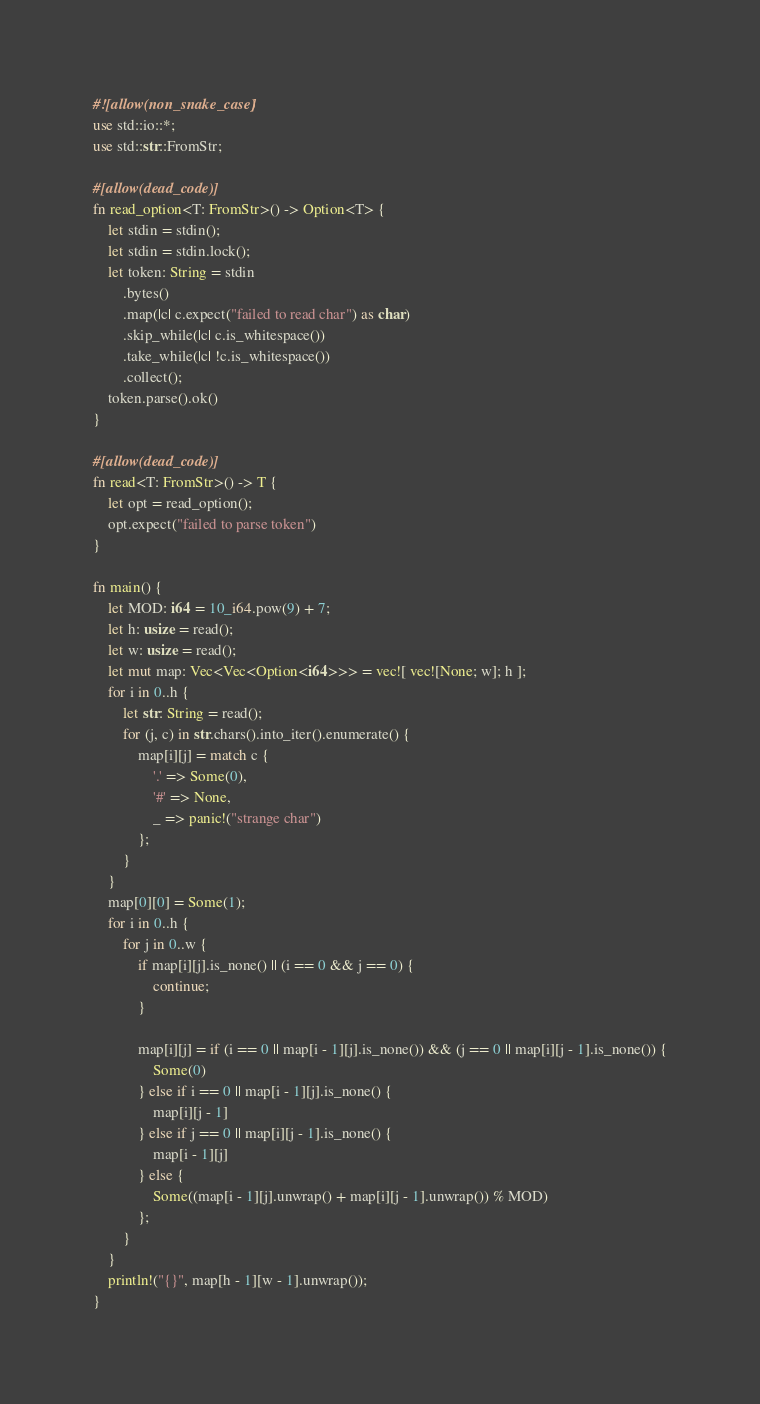Convert code to text. <code><loc_0><loc_0><loc_500><loc_500><_Rust_>#![allow(non_snake_case)]
use std::io::*;
use std::str::FromStr;

#[allow(dead_code)]
fn read_option<T: FromStr>() -> Option<T> {
    let stdin = stdin();
    let stdin = stdin.lock();
    let token: String = stdin
        .bytes()
        .map(|c| c.expect("failed to read char") as char)
        .skip_while(|c| c.is_whitespace())
        .take_while(|c| !c.is_whitespace())
        .collect();
    token.parse().ok()
}

#[allow(dead_code)]
fn read<T: FromStr>() -> T {
    let opt = read_option();
    opt.expect("failed to parse token")
}

fn main() {
    let MOD: i64 = 10_i64.pow(9) + 7;
    let h: usize = read();
    let w: usize = read();
    let mut map: Vec<Vec<Option<i64>>> = vec![ vec![None; w]; h ];
    for i in 0..h {
        let str: String = read();
        for (j, c) in str.chars().into_iter().enumerate() {
            map[i][j] = match c {
                '.' => Some(0),
                '#' => None,
                _ => panic!("strange char")
            };
        }
    }
    map[0][0] = Some(1);
    for i in 0..h {
        for j in 0..w {
            if map[i][j].is_none() || (i == 0 && j == 0) {
                continue;
            }

            map[i][j] = if (i == 0 || map[i - 1][j].is_none()) && (j == 0 || map[i][j - 1].is_none()) {
                Some(0)
            } else if i == 0 || map[i - 1][j].is_none() {
                map[i][j - 1]
            } else if j == 0 || map[i][j - 1].is_none() {
                map[i - 1][j]
            } else {
                Some((map[i - 1][j].unwrap() + map[i][j - 1].unwrap()) % MOD)
            };
        }
    }
    println!("{}", map[h - 1][w - 1].unwrap());
}
</code> 